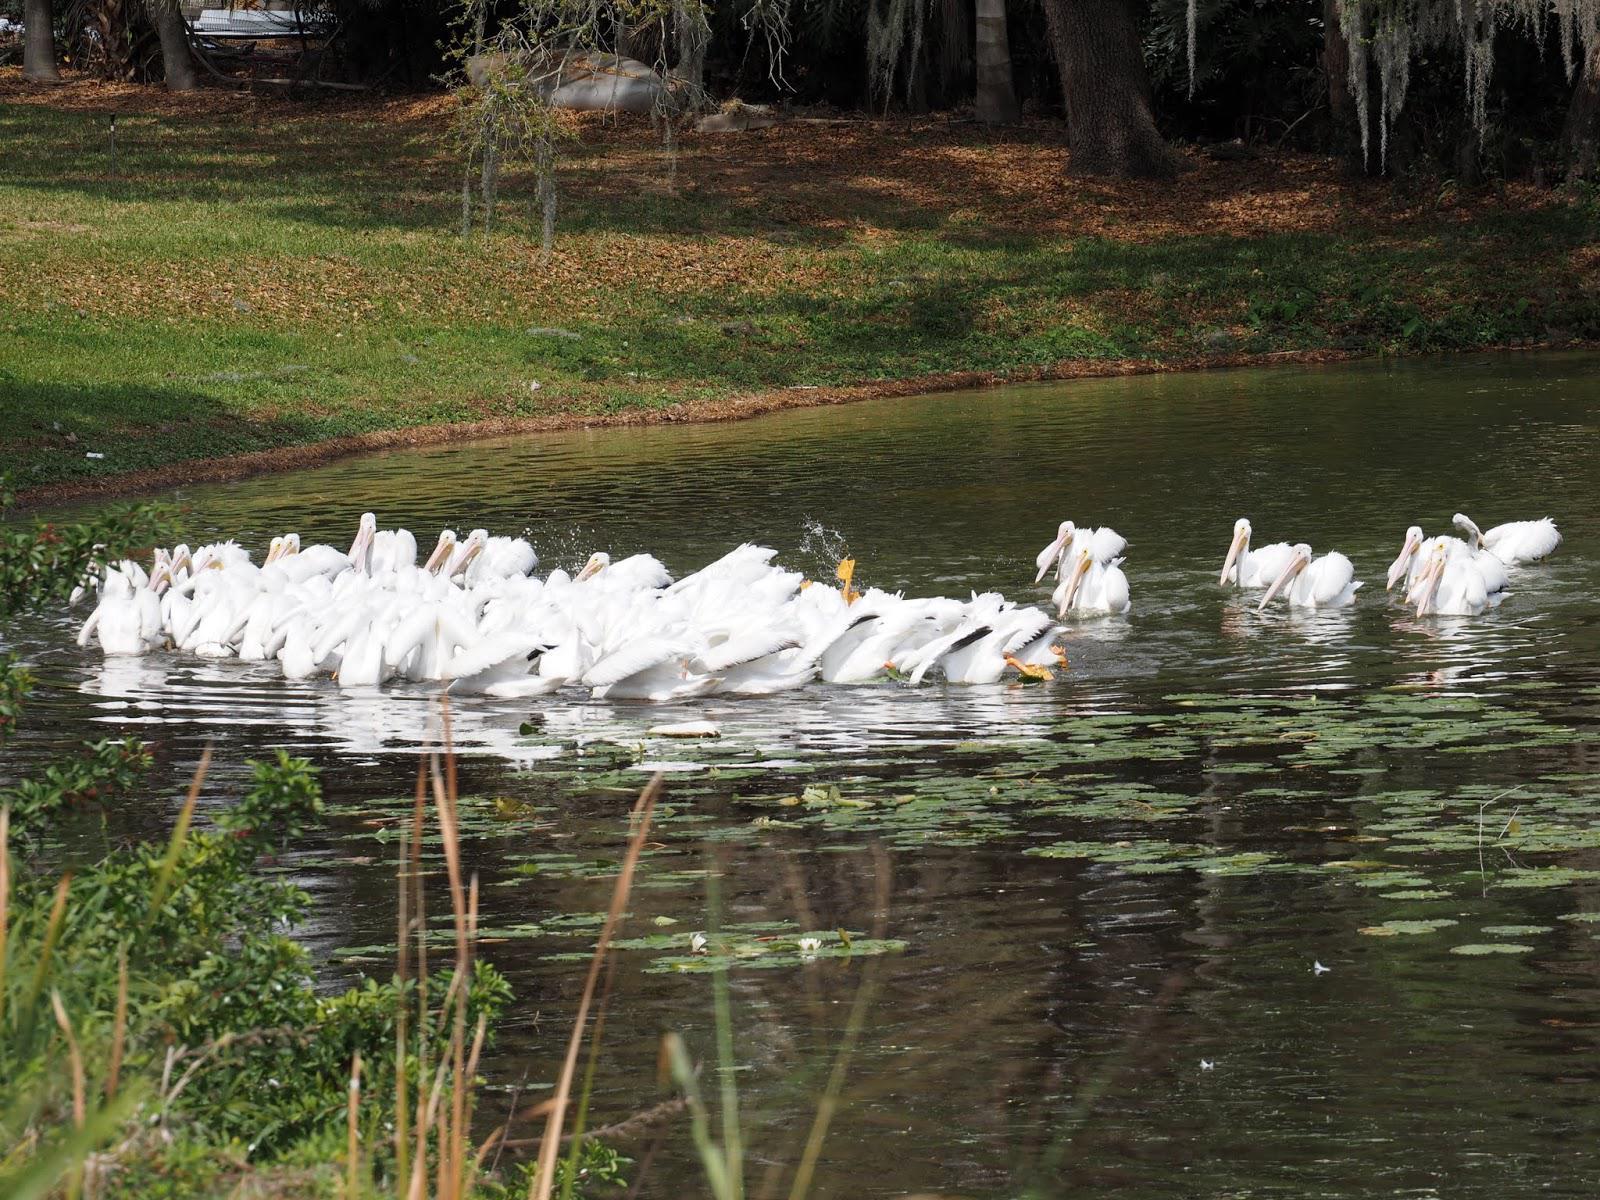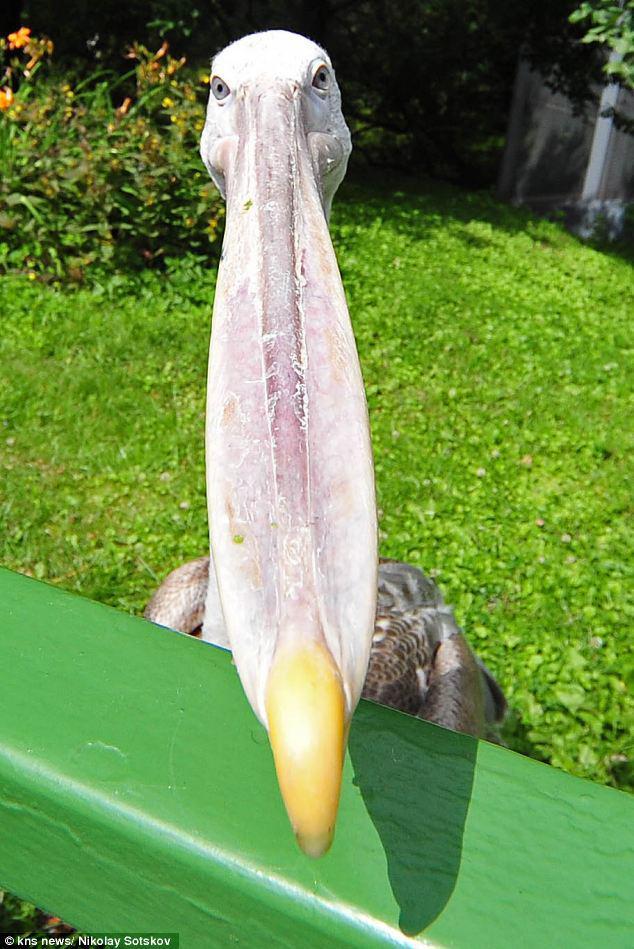The first image is the image on the left, the second image is the image on the right. For the images shown, is this caption "There is only one bird in one of the images." true? Answer yes or no. Yes. The first image is the image on the left, the second image is the image on the right. For the images displayed, is the sentence "there is one bird in the right side photo" factually correct? Answer yes or no. Yes. 